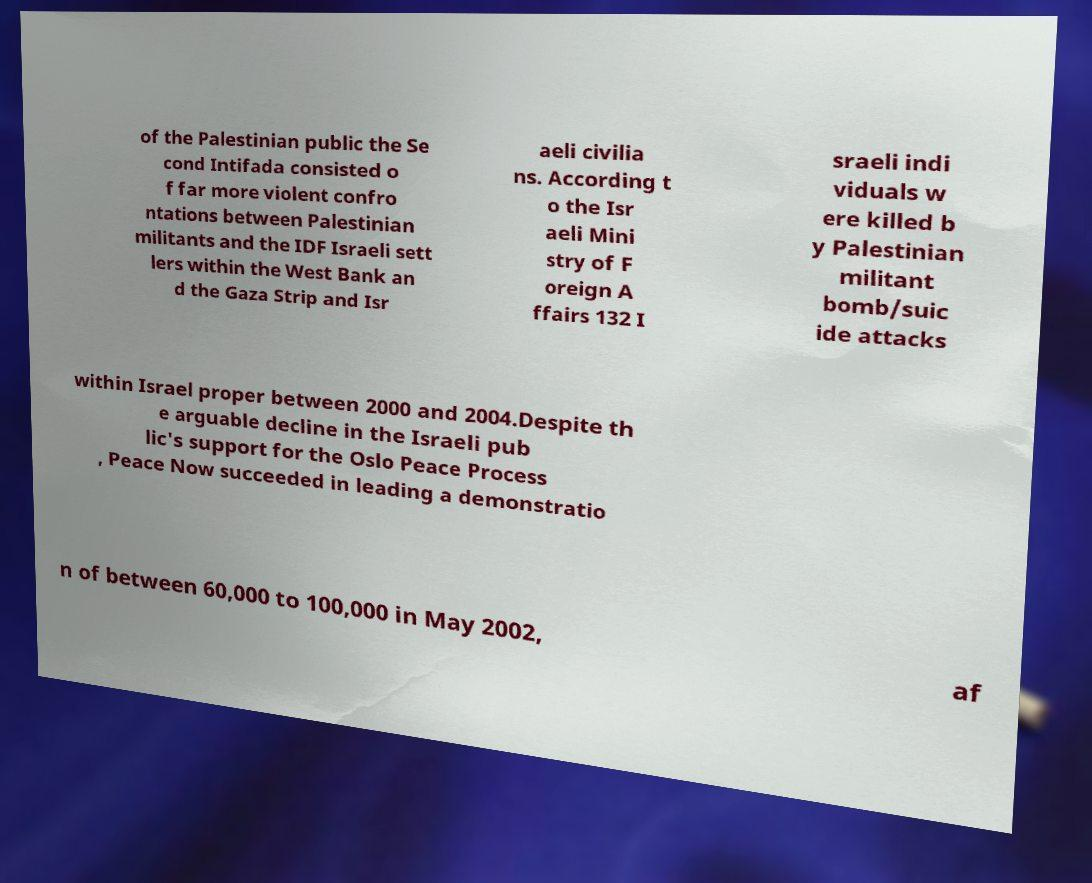Please identify and transcribe the text found in this image. of the Palestinian public the Se cond Intifada consisted o f far more violent confro ntations between Palestinian militants and the IDF Israeli sett lers within the West Bank an d the Gaza Strip and Isr aeli civilia ns. According t o the Isr aeli Mini stry of F oreign A ffairs 132 I sraeli indi viduals w ere killed b y Palestinian militant bomb/suic ide attacks within Israel proper between 2000 and 2004.Despite th e arguable decline in the Israeli pub lic's support for the Oslo Peace Process , Peace Now succeeded in leading a demonstratio n of between 60,000 to 100,000 in May 2002, af 